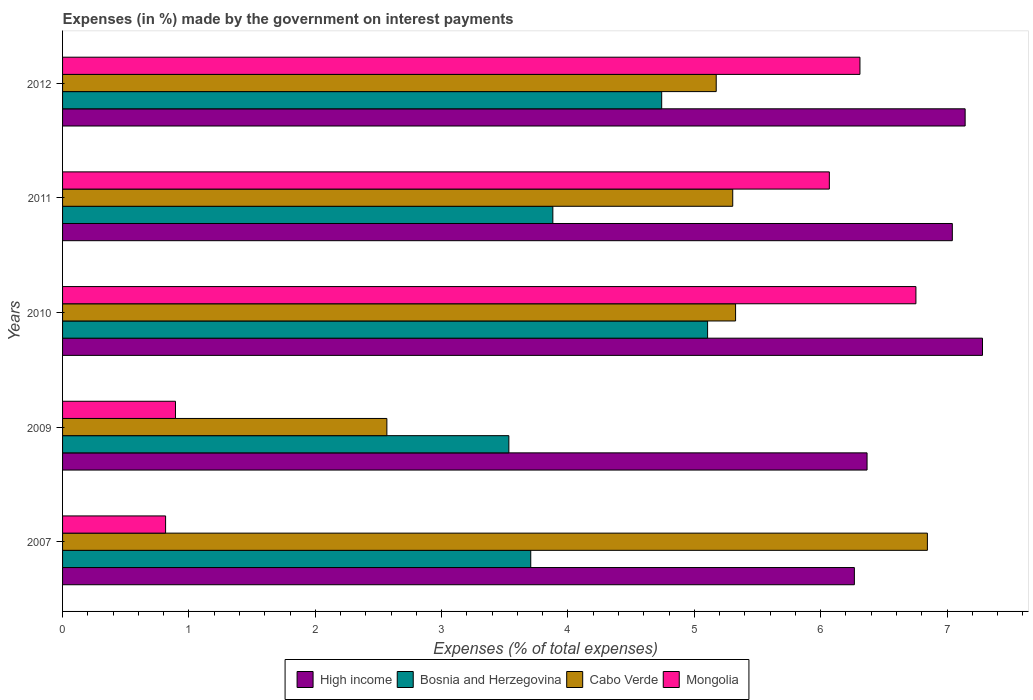How many different coloured bars are there?
Your answer should be very brief. 4. How many groups of bars are there?
Your answer should be very brief. 5. Are the number of bars per tick equal to the number of legend labels?
Make the answer very short. Yes. How many bars are there on the 2nd tick from the top?
Keep it short and to the point. 4. How many bars are there on the 3rd tick from the bottom?
Offer a very short reply. 4. What is the percentage of expenses made by the government on interest payments in Mongolia in 2009?
Ensure brevity in your answer.  0.89. Across all years, what is the maximum percentage of expenses made by the government on interest payments in Mongolia?
Your answer should be compact. 6.75. Across all years, what is the minimum percentage of expenses made by the government on interest payments in High income?
Offer a very short reply. 6.27. What is the total percentage of expenses made by the government on interest payments in Mongolia in the graph?
Offer a terse response. 20.84. What is the difference between the percentage of expenses made by the government on interest payments in High income in 2007 and that in 2012?
Provide a short and direct response. -0.88. What is the difference between the percentage of expenses made by the government on interest payments in High income in 2011 and the percentage of expenses made by the government on interest payments in Bosnia and Herzegovina in 2007?
Your response must be concise. 3.34. What is the average percentage of expenses made by the government on interest payments in High income per year?
Your response must be concise. 6.82. In the year 2009, what is the difference between the percentage of expenses made by the government on interest payments in Bosnia and Herzegovina and percentage of expenses made by the government on interest payments in Cabo Verde?
Your answer should be very brief. 0.97. What is the ratio of the percentage of expenses made by the government on interest payments in Bosnia and Herzegovina in 2010 to that in 2012?
Offer a terse response. 1.08. Is the percentage of expenses made by the government on interest payments in Bosnia and Herzegovina in 2007 less than that in 2011?
Make the answer very short. Yes. Is the difference between the percentage of expenses made by the government on interest payments in Bosnia and Herzegovina in 2009 and 2011 greater than the difference between the percentage of expenses made by the government on interest payments in Cabo Verde in 2009 and 2011?
Offer a terse response. Yes. What is the difference between the highest and the second highest percentage of expenses made by the government on interest payments in High income?
Offer a terse response. 0.14. What is the difference between the highest and the lowest percentage of expenses made by the government on interest payments in Cabo Verde?
Make the answer very short. 4.28. Is it the case that in every year, the sum of the percentage of expenses made by the government on interest payments in High income and percentage of expenses made by the government on interest payments in Bosnia and Herzegovina is greater than the sum of percentage of expenses made by the government on interest payments in Cabo Verde and percentage of expenses made by the government on interest payments in Mongolia?
Offer a terse response. Yes. What does the 1st bar from the top in 2007 represents?
Your response must be concise. Mongolia. What does the 2nd bar from the bottom in 2011 represents?
Your response must be concise. Bosnia and Herzegovina. Is it the case that in every year, the sum of the percentage of expenses made by the government on interest payments in Cabo Verde and percentage of expenses made by the government on interest payments in Bosnia and Herzegovina is greater than the percentage of expenses made by the government on interest payments in Mongolia?
Give a very brief answer. Yes. What is the difference between two consecutive major ticks on the X-axis?
Offer a terse response. 1. Does the graph contain any zero values?
Provide a short and direct response. No. Does the graph contain grids?
Offer a terse response. No. How many legend labels are there?
Offer a terse response. 4. How are the legend labels stacked?
Your response must be concise. Horizontal. What is the title of the graph?
Make the answer very short. Expenses (in %) made by the government on interest payments. Does "Seychelles" appear as one of the legend labels in the graph?
Offer a terse response. No. What is the label or title of the X-axis?
Your answer should be very brief. Expenses (% of total expenses). What is the Expenses (% of total expenses) in High income in 2007?
Ensure brevity in your answer.  6.27. What is the Expenses (% of total expenses) in Bosnia and Herzegovina in 2007?
Your answer should be compact. 3.71. What is the Expenses (% of total expenses) of Cabo Verde in 2007?
Offer a very short reply. 6.84. What is the Expenses (% of total expenses) of Mongolia in 2007?
Your answer should be very brief. 0.82. What is the Expenses (% of total expenses) in High income in 2009?
Keep it short and to the point. 6.37. What is the Expenses (% of total expenses) of Bosnia and Herzegovina in 2009?
Your answer should be compact. 3.53. What is the Expenses (% of total expenses) in Cabo Verde in 2009?
Offer a terse response. 2.57. What is the Expenses (% of total expenses) in Mongolia in 2009?
Your answer should be compact. 0.89. What is the Expenses (% of total expenses) of High income in 2010?
Make the answer very short. 7.28. What is the Expenses (% of total expenses) of Bosnia and Herzegovina in 2010?
Offer a very short reply. 5.11. What is the Expenses (% of total expenses) in Cabo Verde in 2010?
Provide a succinct answer. 5.33. What is the Expenses (% of total expenses) of Mongolia in 2010?
Keep it short and to the point. 6.75. What is the Expenses (% of total expenses) of High income in 2011?
Your response must be concise. 7.04. What is the Expenses (% of total expenses) of Bosnia and Herzegovina in 2011?
Provide a succinct answer. 3.88. What is the Expenses (% of total expenses) in Cabo Verde in 2011?
Keep it short and to the point. 5.3. What is the Expenses (% of total expenses) in Mongolia in 2011?
Keep it short and to the point. 6.07. What is the Expenses (% of total expenses) in High income in 2012?
Offer a terse response. 7.14. What is the Expenses (% of total expenses) in Bosnia and Herzegovina in 2012?
Your answer should be compact. 4.74. What is the Expenses (% of total expenses) of Cabo Verde in 2012?
Ensure brevity in your answer.  5.17. What is the Expenses (% of total expenses) in Mongolia in 2012?
Offer a very short reply. 6.31. Across all years, what is the maximum Expenses (% of total expenses) of High income?
Provide a succinct answer. 7.28. Across all years, what is the maximum Expenses (% of total expenses) in Bosnia and Herzegovina?
Your answer should be compact. 5.11. Across all years, what is the maximum Expenses (% of total expenses) of Cabo Verde?
Give a very brief answer. 6.84. Across all years, what is the maximum Expenses (% of total expenses) in Mongolia?
Give a very brief answer. 6.75. Across all years, what is the minimum Expenses (% of total expenses) of High income?
Give a very brief answer. 6.27. Across all years, what is the minimum Expenses (% of total expenses) of Bosnia and Herzegovina?
Offer a terse response. 3.53. Across all years, what is the minimum Expenses (% of total expenses) in Cabo Verde?
Offer a very short reply. 2.57. Across all years, what is the minimum Expenses (% of total expenses) in Mongolia?
Your response must be concise. 0.82. What is the total Expenses (% of total expenses) in High income in the graph?
Your answer should be very brief. 34.1. What is the total Expenses (% of total expenses) of Bosnia and Herzegovina in the graph?
Provide a short and direct response. 20.96. What is the total Expenses (% of total expenses) in Cabo Verde in the graph?
Ensure brevity in your answer.  25.22. What is the total Expenses (% of total expenses) in Mongolia in the graph?
Your response must be concise. 20.84. What is the difference between the Expenses (% of total expenses) of High income in 2007 and that in 2009?
Your answer should be compact. -0.1. What is the difference between the Expenses (% of total expenses) in Bosnia and Herzegovina in 2007 and that in 2009?
Provide a short and direct response. 0.17. What is the difference between the Expenses (% of total expenses) of Cabo Verde in 2007 and that in 2009?
Provide a succinct answer. 4.28. What is the difference between the Expenses (% of total expenses) of Mongolia in 2007 and that in 2009?
Make the answer very short. -0.08. What is the difference between the Expenses (% of total expenses) of High income in 2007 and that in 2010?
Your response must be concise. -1.01. What is the difference between the Expenses (% of total expenses) in Bosnia and Herzegovina in 2007 and that in 2010?
Offer a terse response. -1.4. What is the difference between the Expenses (% of total expenses) of Cabo Verde in 2007 and that in 2010?
Provide a succinct answer. 1.52. What is the difference between the Expenses (% of total expenses) of Mongolia in 2007 and that in 2010?
Offer a very short reply. -5.94. What is the difference between the Expenses (% of total expenses) of High income in 2007 and that in 2011?
Provide a succinct answer. -0.78. What is the difference between the Expenses (% of total expenses) of Bosnia and Herzegovina in 2007 and that in 2011?
Make the answer very short. -0.17. What is the difference between the Expenses (% of total expenses) in Cabo Verde in 2007 and that in 2011?
Keep it short and to the point. 1.54. What is the difference between the Expenses (% of total expenses) in Mongolia in 2007 and that in 2011?
Make the answer very short. -5.25. What is the difference between the Expenses (% of total expenses) in High income in 2007 and that in 2012?
Ensure brevity in your answer.  -0.88. What is the difference between the Expenses (% of total expenses) of Bosnia and Herzegovina in 2007 and that in 2012?
Your answer should be very brief. -1.04. What is the difference between the Expenses (% of total expenses) in Cabo Verde in 2007 and that in 2012?
Keep it short and to the point. 1.67. What is the difference between the Expenses (% of total expenses) of Mongolia in 2007 and that in 2012?
Offer a very short reply. -5.5. What is the difference between the Expenses (% of total expenses) in High income in 2009 and that in 2010?
Provide a short and direct response. -0.91. What is the difference between the Expenses (% of total expenses) in Bosnia and Herzegovina in 2009 and that in 2010?
Your answer should be compact. -1.57. What is the difference between the Expenses (% of total expenses) of Cabo Verde in 2009 and that in 2010?
Make the answer very short. -2.76. What is the difference between the Expenses (% of total expenses) of Mongolia in 2009 and that in 2010?
Your response must be concise. -5.86. What is the difference between the Expenses (% of total expenses) of High income in 2009 and that in 2011?
Offer a terse response. -0.67. What is the difference between the Expenses (% of total expenses) of Bosnia and Herzegovina in 2009 and that in 2011?
Provide a short and direct response. -0.35. What is the difference between the Expenses (% of total expenses) in Cabo Verde in 2009 and that in 2011?
Keep it short and to the point. -2.74. What is the difference between the Expenses (% of total expenses) of Mongolia in 2009 and that in 2011?
Offer a terse response. -5.17. What is the difference between the Expenses (% of total expenses) in High income in 2009 and that in 2012?
Your answer should be compact. -0.78. What is the difference between the Expenses (% of total expenses) in Bosnia and Herzegovina in 2009 and that in 2012?
Make the answer very short. -1.21. What is the difference between the Expenses (% of total expenses) of Cabo Verde in 2009 and that in 2012?
Your answer should be compact. -2.61. What is the difference between the Expenses (% of total expenses) in Mongolia in 2009 and that in 2012?
Make the answer very short. -5.42. What is the difference between the Expenses (% of total expenses) in High income in 2010 and that in 2011?
Your response must be concise. 0.24. What is the difference between the Expenses (% of total expenses) of Bosnia and Herzegovina in 2010 and that in 2011?
Offer a terse response. 1.22. What is the difference between the Expenses (% of total expenses) of Cabo Verde in 2010 and that in 2011?
Offer a very short reply. 0.02. What is the difference between the Expenses (% of total expenses) in Mongolia in 2010 and that in 2011?
Provide a succinct answer. 0.69. What is the difference between the Expenses (% of total expenses) in High income in 2010 and that in 2012?
Your answer should be compact. 0.14. What is the difference between the Expenses (% of total expenses) of Bosnia and Herzegovina in 2010 and that in 2012?
Offer a very short reply. 0.36. What is the difference between the Expenses (% of total expenses) in Cabo Verde in 2010 and that in 2012?
Keep it short and to the point. 0.15. What is the difference between the Expenses (% of total expenses) in Mongolia in 2010 and that in 2012?
Your response must be concise. 0.44. What is the difference between the Expenses (% of total expenses) of High income in 2011 and that in 2012?
Your answer should be compact. -0.1. What is the difference between the Expenses (% of total expenses) in Bosnia and Herzegovina in 2011 and that in 2012?
Make the answer very short. -0.86. What is the difference between the Expenses (% of total expenses) of Cabo Verde in 2011 and that in 2012?
Provide a succinct answer. 0.13. What is the difference between the Expenses (% of total expenses) of Mongolia in 2011 and that in 2012?
Ensure brevity in your answer.  -0.24. What is the difference between the Expenses (% of total expenses) of High income in 2007 and the Expenses (% of total expenses) of Bosnia and Herzegovina in 2009?
Your answer should be very brief. 2.73. What is the difference between the Expenses (% of total expenses) in High income in 2007 and the Expenses (% of total expenses) in Cabo Verde in 2009?
Your response must be concise. 3.7. What is the difference between the Expenses (% of total expenses) in High income in 2007 and the Expenses (% of total expenses) in Mongolia in 2009?
Ensure brevity in your answer.  5.37. What is the difference between the Expenses (% of total expenses) in Bosnia and Herzegovina in 2007 and the Expenses (% of total expenses) in Cabo Verde in 2009?
Provide a succinct answer. 1.14. What is the difference between the Expenses (% of total expenses) of Bosnia and Herzegovina in 2007 and the Expenses (% of total expenses) of Mongolia in 2009?
Give a very brief answer. 2.81. What is the difference between the Expenses (% of total expenses) in Cabo Verde in 2007 and the Expenses (% of total expenses) in Mongolia in 2009?
Keep it short and to the point. 5.95. What is the difference between the Expenses (% of total expenses) of High income in 2007 and the Expenses (% of total expenses) of Bosnia and Herzegovina in 2010?
Your answer should be compact. 1.16. What is the difference between the Expenses (% of total expenses) of High income in 2007 and the Expenses (% of total expenses) of Cabo Verde in 2010?
Ensure brevity in your answer.  0.94. What is the difference between the Expenses (% of total expenses) of High income in 2007 and the Expenses (% of total expenses) of Mongolia in 2010?
Ensure brevity in your answer.  -0.49. What is the difference between the Expenses (% of total expenses) in Bosnia and Herzegovina in 2007 and the Expenses (% of total expenses) in Cabo Verde in 2010?
Make the answer very short. -1.62. What is the difference between the Expenses (% of total expenses) in Bosnia and Herzegovina in 2007 and the Expenses (% of total expenses) in Mongolia in 2010?
Your response must be concise. -3.05. What is the difference between the Expenses (% of total expenses) in Cabo Verde in 2007 and the Expenses (% of total expenses) in Mongolia in 2010?
Offer a terse response. 0.09. What is the difference between the Expenses (% of total expenses) of High income in 2007 and the Expenses (% of total expenses) of Bosnia and Herzegovina in 2011?
Offer a very short reply. 2.39. What is the difference between the Expenses (% of total expenses) in High income in 2007 and the Expenses (% of total expenses) in Cabo Verde in 2011?
Your answer should be very brief. 0.96. What is the difference between the Expenses (% of total expenses) of High income in 2007 and the Expenses (% of total expenses) of Mongolia in 2011?
Give a very brief answer. 0.2. What is the difference between the Expenses (% of total expenses) of Bosnia and Herzegovina in 2007 and the Expenses (% of total expenses) of Cabo Verde in 2011?
Provide a succinct answer. -1.6. What is the difference between the Expenses (% of total expenses) in Bosnia and Herzegovina in 2007 and the Expenses (% of total expenses) in Mongolia in 2011?
Make the answer very short. -2.36. What is the difference between the Expenses (% of total expenses) of Cabo Verde in 2007 and the Expenses (% of total expenses) of Mongolia in 2011?
Keep it short and to the point. 0.78. What is the difference between the Expenses (% of total expenses) of High income in 2007 and the Expenses (% of total expenses) of Bosnia and Herzegovina in 2012?
Your answer should be compact. 1.52. What is the difference between the Expenses (% of total expenses) of High income in 2007 and the Expenses (% of total expenses) of Cabo Verde in 2012?
Keep it short and to the point. 1.09. What is the difference between the Expenses (% of total expenses) of High income in 2007 and the Expenses (% of total expenses) of Mongolia in 2012?
Your answer should be very brief. -0.04. What is the difference between the Expenses (% of total expenses) of Bosnia and Herzegovina in 2007 and the Expenses (% of total expenses) of Cabo Verde in 2012?
Make the answer very short. -1.47. What is the difference between the Expenses (% of total expenses) of Bosnia and Herzegovina in 2007 and the Expenses (% of total expenses) of Mongolia in 2012?
Make the answer very short. -2.61. What is the difference between the Expenses (% of total expenses) in Cabo Verde in 2007 and the Expenses (% of total expenses) in Mongolia in 2012?
Give a very brief answer. 0.53. What is the difference between the Expenses (% of total expenses) of High income in 2009 and the Expenses (% of total expenses) of Bosnia and Herzegovina in 2010?
Give a very brief answer. 1.26. What is the difference between the Expenses (% of total expenses) of High income in 2009 and the Expenses (% of total expenses) of Cabo Verde in 2010?
Provide a succinct answer. 1.04. What is the difference between the Expenses (% of total expenses) of High income in 2009 and the Expenses (% of total expenses) of Mongolia in 2010?
Provide a succinct answer. -0.39. What is the difference between the Expenses (% of total expenses) in Bosnia and Herzegovina in 2009 and the Expenses (% of total expenses) in Cabo Verde in 2010?
Give a very brief answer. -1.79. What is the difference between the Expenses (% of total expenses) of Bosnia and Herzegovina in 2009 and the Expenses (% of total expenses) of Mongolia in 2010?
Give a very brief answer. -3.22. What is the difference between the Expenses (% of total expenses) of Cabo Verde in 2009 and the Expenses (% of total expenses) of Mongolia in 2010?
Offer a terse response. -4.19. What is the difference between the Expenses (% of total expenses) in High income in 2009 and the Expenses (% of total expenses) in Bosnia and Herzegovina in 2011?
Make the answer very short. 2.49. What is the difference between the Expenses (% of total expenses) in High income in 2009 and the Expenses (% of total expenses) in Cabo Verde in 2011?
Your answer should be very brief. 1.06. What is the difference between the Expenses (% of total expenses) of High income in 2009 and the Expenses (% of total expenses) of Mongolia in 2011?
Provide a short and direct response. 0.3. What is the difference between the Expenses (% of total expenses) of Bosnia and Herzegovina in 2009 and the Expenses (% of total expenses) of Cabo Verde in 2011?
Make the answer very short. -1.77. What is the difference between the Expenses (% of total expenses) in Bosnia and Herzegovina in 2009 and the Expenses (% of total expenses) in Mongolia in 2011?
Your response must be concise. -2.54. What is the difference between the Expenses (% of total expenses) in Cabo Verde in 2009 and the Expenses (% of total expenses) in Mongolia in 2011?
Offer a terse response. -3.5. What is the difference between the Expenses (% of total expenses) of High income in 2009 and the Expenses (% of total expenses) of Bosnia and Herzegovina in 2012?
Keep it short and to the point. 1.63. What is the difference between the Expenses (% of total expenses) of High income in 2009 and the Expenses (% of total expenses) of Cabo Verde in 2012?
Ensure brevity in your answer.  1.19. What is the difference between the Expenses (% of total expenses) in High income in 2009 and the Expenses (% of total expenses) in Mongolia in 2012?
Your response must be concise. 0.06. What is the difference between the Expenses (% of total expenses) in Bosnia and Herzegovina in 2009 and the Expenses (% of total expenses) in Cabo Verde in 2012?
Make the answer very short. -1.64. What is the difference between the Expenses (% of total expenses) of Bosnia and Herzegovina in 2009 and the Expenses (% of total expenses) of Mongolia in 2012?
Give a very brief answer. -2.78. What is the difference between the Expenses (% of total expenses) in Cabo Verde in 2009 and the Expenses (% of total expenses) in Mongolia in 2012?
Offer a terse response. -3.74. What is the difference between the Expenses (% of total expenses) of High income in 2010 and the Expenses (% of total expenses) of Bosnia and Herzegovina in 2011?
Offer a terse response. 3.4. What is the difference between the Expenses (% of total expenses) in High income in 2010 and the Expenses (% of total expenses) in Cabo Verde in 2011?
Your answer should be very brief. 1.98. What is the difference between the Expenses (% of total expenses) in High income in 2010 and the Expenses (% of total expenses) in Mongolia in 2011?
Make the answer very short. 1.21. What is the difference between the Expenses (% of total expenses) in Bosnia and Herzegovina in 2010 and the Expenses (% of total expenses) in Cabo Verde in 2011?
Make the answer very short. -0.2. What is the difference between the Expenses (% of total expenses) in Bosnia and Herzegovina in 2010 and the Expenses (% of total expenses) in Mongolia in 2011?
Provide a succinct answer. -0.96. What is the difference between the Expenses (% of total expenses) of Cabo Verde in 2010 and the Expenses (% of total expenses) of Mongolia in 2011?
Ensure brevity in your answer.  -0.74. What is the difference between the Expenses (% of total expenses) in High income in 2010 and the Expenses (% of total expenses) in Bosnia and Herzegovina in 2012?
Ensure brevity in your answer.  2.54. What is the difference between the Expenses (% of total expenses) of High income in 2010 and the Expenses (% of total expenses) of Cabo Verde in 2012?
Your answer should be very brief. 2.11. What is the difference between the Expenses (% of total expenses) in High income in 2010 and the Expenses (% of total expenses) in Mongolia in 2012?
Offer a terse response. 0.97. What is the difference between the Expenses (% of total expenses) of Bosnia and Herzegovina in 2010 and the Expenses (% of total expenses) of Cabo Verde in 2012?
Provide a succinct answer. -0.07. What is the difference between the Expenses (% of total expenses) in Bosnia and Herzegovina in 2010 and the Expenses (% of total expenses) in Mongolia in 2012?
Offer a terse response. -1.21. What is the difference between the Expenses (% of total expenses) of Cabo Verde in 2010 and the Expenses (% of total expenses) of Mongolia in 2012?
Provide a short and direct response. -0.98. What is the difference between the Expenses (% of total expenses) of High income in 2011 and the Expenses (% of total expenses) of Bosnia and Herzegovina in 2012?
Your answer should be very brief. 2.3. What is the difference between the Expenses (% of total expenses) in High income in 2011 and the Expenses (% of total expenses) in Cabo Verde in 2012?
Keep it short and to the point. 1.87. What is the difference between the Expenses (% of total expenses) of High income in 2011 and the Expenses (% of total expenses) of Mongolia in 2012?
Offer a very short reply. 0.73. What is the difference between the Expenses (% of total expenses) in Bosnia and Herzegovina in 2011 and the Expenses (% of total expenses) in Cabo Verde in 2012?
Your answer should be very brief. -1.29. What is the difference between the Expenses (% of total expenses) of Bosnia and Herzegovina in 2011 and the Expenses (% of total expenses) of Mongolia in 2012?
Offer a terse response. -2.43. What is the difference between the Expenses (% of total expenses) in Cabo Verde in 2011 and the Expenses (% of total expenses) in Mongolia in 2012?
Offer a very short reply. -1.01. What is the average Expenses (% of total expenses) in High income per year?
Make the answer very short. 6.82. What is the average Expenses (% of total expenses) of Bosnia and Herzegovina per year?
Give a very brief answer. 4.19. What is the average Expenses (% of total expenses) of Cabo Verde per year?
Your answer should be very brief. 5.04. What is the average Expenses (% of total expenses) of Mongolia per year?
Your answer should be very brief. 4.17. In the year 2007, what is the difference between the Expenses (% of total expenses) of High income and Expenses (% of total expenses) of Bosnia and Herzegovina?
Make the answer very short. 2.56. In the year 2007, what is the difference between the Expenses (% of total expenses) of High income and Expenses (% of total expenses) of Cabo Verde?
Make the answer very short. -0.58. In the year 2007, what is the difference between the Expenses (% of total expenses) in High income and Expenses (% of total expenses) in Mongolia?
Give a very brief answer. 5.45. In the year 2007, what is the difference between the Expenses (% of total expenses) in Bosnia and Herzegovina and Expenses (% of total expenses) in Cabo Verde?
Make the answer very short. -3.14. In the year 2007, what is the difference between the Expenses (% of total expenses) in Bosnia and Herzegovina and Expenses (% of total expenses) in Mongolia?
Give a very brief answer. 2.89. In the year 2007, what is the difference between the Expenses (% of total expenses) in Cabo Verde and Expenses (% of total expenses) in Mongolia?
Offer a terse response. 6.03. In the year 2009, what is the difference between the Expenses (% of total expenses) of High income and Expenses (% of total expenses) of Bosnia and Herzegovina?
Offer a very short reply. 2.83. In the year 2009, what is the difference between the Expenses (% of total expenses) in High income and Expenses (% of total expenses) in Cabo Verde?
Ensure brevity in your answer.  3.8. In the year 2009, what is the difference between the Expenses (% of total expenses) of High income and Expenses (% of total expenses) of Mongolia?
Offer a terse response. 5.47. In the year 2009, what is the difference between the Expenses (% of total expenses) in Bosnia and Herzegovina and Expenses (% of total expenses) in Cabo Verde?
Provide a short and direct response. 0.97. In the year 2009, what is the difference between the Expenses (% of total expenses) of Bosnia and Herzegovina and Expenses (% of total expenses) of Mongolia?
Give a very brief answer. 2.64. In the year 2009, what is the difference between the Expenses (% of total expenses) of Cabo Verde and Expenses (% of total expenses) of Mongolia?
Ensure brevity in your answer.  1.67. In the year 2010, what is the difference between the Expenses (% of total expenses) in High income and Expenses (% of total expenses) in Bosnia and Herzegovina?
Offer a terse response. 2.18. In the year 2010, what is the difference between the Expenses (% of total expenses) of High income and Expenses (% of total expenses) of Cabo Verde?
Your answer should be very brief. 1.95. In the year 2010, what is the difference between the Expenses (% of total expenses) of High income and Expenses (% of total expenses) of Mongolia?
Provide a succinct answer. 0.53. In the year 2010, what is the difference between the Expenses (% of total expenses) of Bosnia and Herzegovina and Expenses (% of total expenses) of Cabo Verde?
Provide a short and direct response. -0.22. In the year 2010, what is the difference between the Expenses (% of total expenses) in Bosnia and Herzegovina and Expenses (% of total expenses) in Mongolia?
Provide a succinct answer. -1.65. In the year 2010, what is the difference between the Expenses (% of total expenses) in Cabo Verde and Expenses (% of total expenses) in Mongolia?
Keep it short and to the point. -1.43. In the year 2011, what is the difference between the Expenses (% of total expenses) in High income and Expenses (% of total expenses) in Bosnia and Herzegovina?
Offer a terse response. 3.16. In the year 2011, what is the difference between the Expenses (% of total expenses) of High income and Expenses (% of total expenses) of Cabo Verde?
Provide a short and direct response. 1.74. In the year 2011, what is the difference between the Expenses (% of total expenses) in High income and Expenses (% of total expenses) in Mongolia?
Ensure brevity in your answer.  0.97. In the year 2011, what is the difference between the Expenses (% of total expenses) in Bosnia and Herzegovina and Expenses (% of total expenses) in Cabo Verde?
Keep it short and to the point. -1.42. In the year 2011, what is the difference between the Expenses (% of total expenses) in Bosnia and Herzegovina and Expenses (% of total expenses) in Mongolia?
Offer a very short reply. -2.19. In the year 2011, what is the difference between the Expenses (% of total expenses) in Cabo Verde and Expenses (% of total expenses) in Mongolia?
Offer a terse response. -0.76. In the year 2012, what is the difference between the Expenses (% of total expenses) of High income and Expenses (% of total expenses) of Bosnia and Herzegovina?
Make the answer very short. 2.4. In the year 2012, what is the difference between the Expenses (% of total expenses) of High income and Expenses (% of total expenses) of Cabo Verde?
Offer a very short reply. 1.97. In the year 2012, what is the difference between the Expenses (% of total expenses) of High income and Expenses (% of total expenses) of Mongolia?
Your answer should be very brief. 0.83. In the year 2012, what is the difference between the Expenses (% of total expenses) of Bosnia and Herzegovina and Expenses (% of total expenses) of Cabo Verde?
Your answer should be very brief. -0.43. In the year 2012, what is the difference between the Expenses (% of total expenses) in Bosnia and Herzegovina and Expenses (% of total expenses) in Mongolia?
Give a very brief answer. -1.57. In the year 2012, what is the difference between the Expenses (% of total expenses) of Cabo Verde and Expenses (% of total expenses) of Mongolia?
Your response must be concise. -1.14. What is the ratio of the Expenses (% of total expenses) of High income in 2007 to that in 2009?
Ensure brevity in your answer.  0.98. What is the ratio of the Expenses (% of total expenses) in Bosnia and Herzegovina in 2007 to that in 2009?
Offer a terse response. 1.05. What is the ratio of the Expenses (% of total expenses) in Cabo Verde in 2007 to that in 2009?
Your answer should be compact. 2.67. What is the ratio of the Expenses (% of total expenses) of Mongolia in 2007 to that in 2009?
Offer a terse response. 0.91. What is the ratio of the Expenses (% of total expenses) in High income in 2007 to that in 2010?
Provide a succinct answer. 0.86. What is the ratio of the Expenses (% of total expenses) of Bosnia and Herzegovina in 2007 to that in 2010?
Your answer should be very brief. 0.73. What is the ratio of the Expenses (% of total expenses) in Cabo Verde in 2007 to that in 2010?
Give a very brief answer. 1.28. What is the ratio of the Expenses (% of total expenses) of Mongolia in 2007 to that in 2010?
Your answer should be very brief. 0.12. What is the ratio of the Expenses (% of total expenses) in High income in 2007 to that in 2011?
Give a very brief answer. 0.89. What is the ratio of the Expenses (% of total expenses) of Bosnia and Herzegovina in 2007 to that in 2011?
Your answer should be compact. 0.95. What is the ratio of the Expenses (% of total expenses) of Cabo Verde in 2007 to that in 2011?
Your answer should be very brief. 1.29. What is the ratio of the Expenses (% of total expenses) of Mongolia in 2007 to that in 2011?
Your answer should be compact. 0.13. What is the ratio of the Expenses (% of total expenses) of High income in 2007 to that in 2012?
Offer a terse response. 0.88. What is the ratio of the Expenses (% of total expenses) in Bosnia and Herzegovina in 2007 to that in 2012?
Offer a terse response. 0.78. What is the ratio of the Expenses (% of total expenses) of Cabo Verde in 2007 to that in 2012?
Your answer should be compact. 1.32. What is the ratio of the Expenses (% of total expenses) in Mongolia in 2007 to that in 2012?
Keep it short and to the point. 0.13. What is the ratio of the Expenses (% of total expenses) of High income in 2009 to that in 2010?
Your answer should be compact. 0.87. What is the ratio of the Expenses (% of total expenses) of Bosnia and Herzegovina in 2009 to that in 2010?
Provide a short and direct response. 0.69. What is the ratio of the Expenses (% of total expenses) in Cabo Verde in 2009 to that in 2010?
Provide a succinct answer. 0.48. What is the ratio of the Expenses (% of total expenses) of Mongolia in 2009 to that in 2010?
Offer a terse response. 0.13. What is the ratio of the Expenses (% of total expenses) in High income in 2009 to that in 2011?
Offer a terse response. 0.9. What is the ratio of the Expenses (% of total expenses) of Bosnia and Herzegovina in 2009 to that in 2011?
Provide a succinct answer. 0.91. What is the ratio of the Expenses (% of total expenses) in Cabo Verde in 2009 to that in 2011?
Provide a short and direct response. 0.48. What is the ratio of the Expenses (% of total expenses) of Mongolia in 2009 to that in 2011?
Give a very brief answer. 0.15. What is the ratio of the Expenses (% of total expenses) of High income in 2009 to that in 2012?
Your response must be concise. 0.89. What is the ratio of the Expenses (% of total expenses) of Bosnia and Herzegovina in 2009 to that in 2012?
Your response must be concise. 0.74. What is the ratio of the Expenses (% of total expenses) in Cabo Verde in 2009 to that in 2012?
Offer a very short reply. 0.5. What is the ratio of the Expenses (% of total expenses) in Mongolia in 2009 to that in 2012?
Keep it short and to the point. 0.14. What is the ratio of the Expenses (% of total expenses) of High income in 2010 to that in 2011?
Your response must be concise. 1.03. What is the ratio of the Expenses (% of total expenses) in Bosnia and Herzegovina in 2010 to that in 2011?
Your answer should be very brief. 1.32. What is the ratio of the Expenses (% of total expenses) of Cabo Verde in 2010 to that in 2011?
Provide a short and direct response. 1. What is the ratio of the Expenses (% of total expenses) of Mongolia in 2010 to that in 2011?
Ensure brevity in your answer.  1.11. What is the ratio of the Expenses (% of total expenses) of High income in 2010 to that in 2012?
Provide a short and direct response. 1.02. What is the ratio of the Expenses (% of total expenses) in Bosnia and Herzegovina in 2010 to that in 2012?
Give a very brief answer. 1.08. What is the ratio of the Expenses (% of total expenses) in Cabo Verde in 2010 to that in 2012?
Ensure brevity in your answer.  1.03. What is the ratio of the Expenses (% of total expenses) of Mongolia in 2010 to that in 2012?
Keep it short and to the point. 1.07. What is the ratio of the Expenses (% of total expenses) in High income in 2011 to that in 2012?
Make the answer very short. 0.99. What is the ratio of the Expenses (% of total expenses) in Bosnia and Herzegovina in 2011 to that in 2012?
Your answer should be very brief. 0.82. What is the ratio of the Expenses (% of total expenses) of Cabo Verde in 2011 to that in 2012?
Your response must be concise. 1.03. What is the ratio of the Expenses (% of total expenses) of Mongolia in 2011 to that in 2012?
Your answer should be compact. 0.96. What is the difference between the highest and the second highest Expenses (% of total expenses) of High income?
Your answer should be compact. 0.14. What is the difference between the highest and the second highest Expenses (% of total expenses) in Bosnia and Herzegovina?
Ensure brevity in your answer.  0.36. What is the difference between the highest and the second highest Expenses (% of total expenses) in Cabo Verde?
Offer a terse response. 1.52. What is the difference between the highest and the second highest Expenses (% of total expenses) of Mongolia?
Offer a terse response. 0.44. What is the difference between the highest and the lowest Expenses (% of total expenses) of High income?
Your answer should be very brief. 1.01. What is the difference between the highest and the lowest Expenses (% of total expenses) of Bosnia and Herzegovina?
Offer a terse response. 1.57. What is the difference between the highest and the lowest Expenses (% of total expenses) of Cabo Verde?
Offer a terse response. 4.28. What is the difference between the highest and the lowest Expenses (% of total expenses) of Mongolia?
Keep it short and to the point. 5.94. 